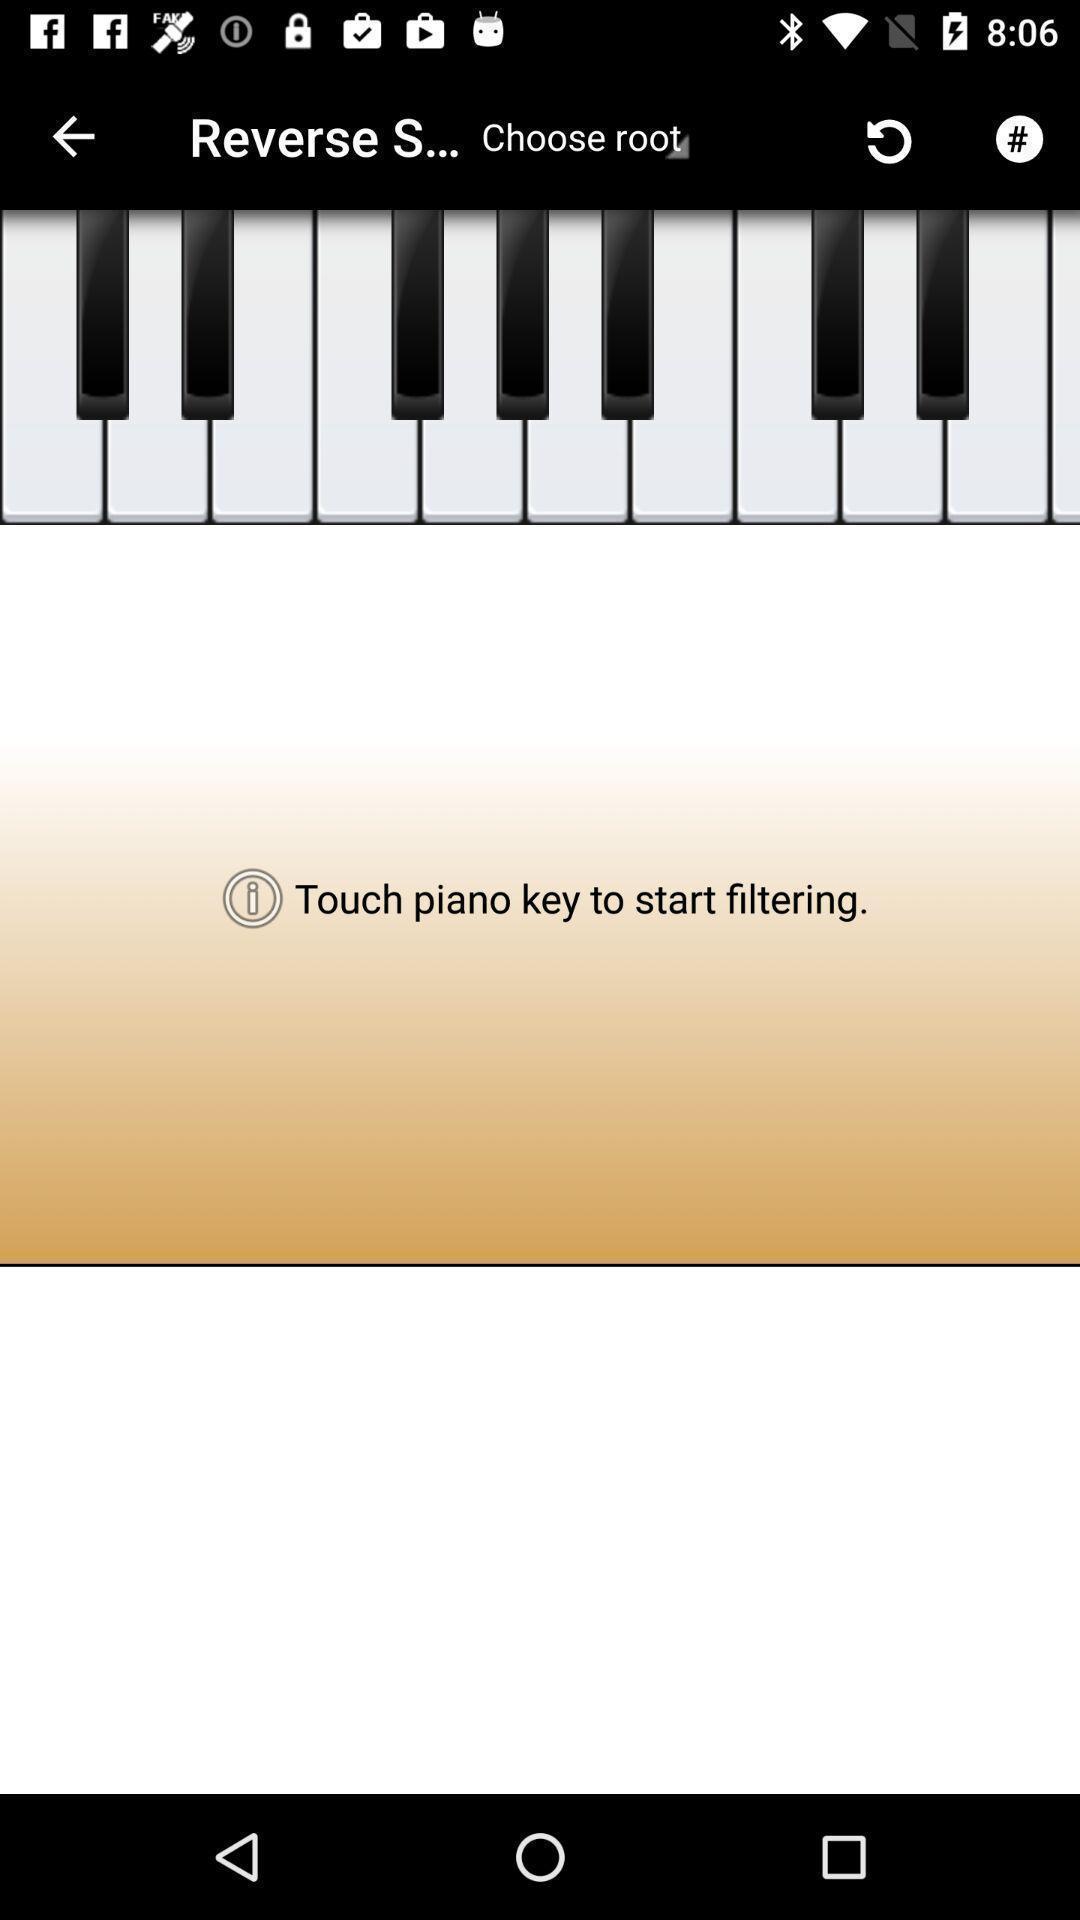Give me a summary of this screen capture. Page of the piano learning app. 